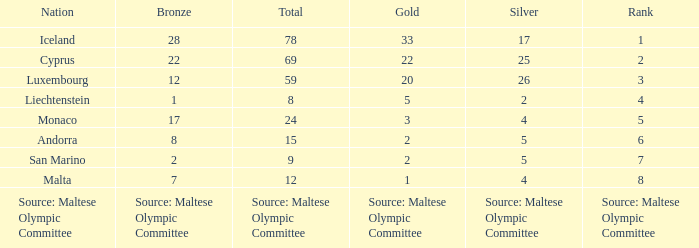What is the total medal count for the nation that has 5 gold? 8.0. 